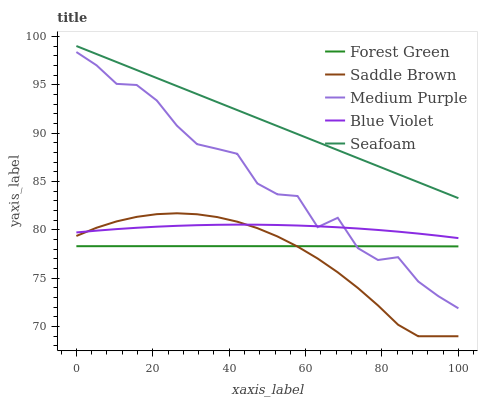Does Saddle Brown have the minimum area under the curve?
Answer yes or no. Yes. Does Seafoam have the maximum area under the curve?
Answer yes or no. Yes. Does Forest Green have the minimum area under the curve?
Answer yes or no. No. Does Forest Green have the maximum area under the curve?
Answer yes or no. No. Is Seafoam the smoothest?
Answer yes or no. Yes. Is Medium Purple the roughest?
Answer yes or no. Yes. Is Forest Green the smoothest?
Answer yes or no. No. Is Forest Green the roughest?
Answer yes or no. No. Does Saddle Brown have the lowest value?
Answer yes or no. Yes. Does Forest Green have the lowest value?
Answer yes or no. No. Does Seafoam have the highest value?
Answer yes or no. Yes. Does Saddle Brown have the highest value?
Answer yes or no. No. Is Forest Green less than Seafoam?
Answer yes or no. Yes. Is Seafoam greater than Blue Violet?
Answer yes or no. Yes. Does Medium Purple intersect Forest Green?
Answer yes or no. Yes. Is Medium Purple less than Forest Green?
Answer yes or no. No. Is Medium Purple greater than Forest Green?
Answer yes or no. No. Does Forest Green intersect Seafoam?
Answer yes or no. No. 